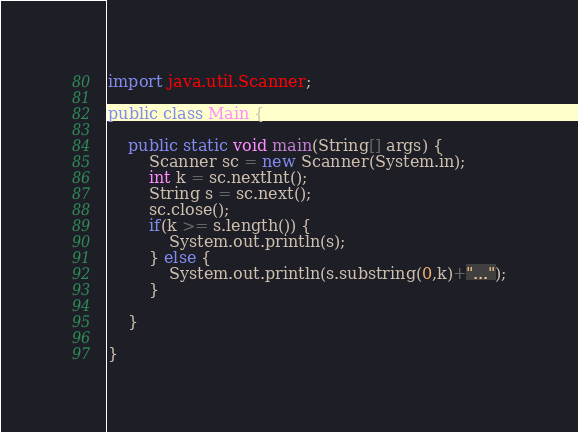Convert code to text. <code><loc_0><loc_0><loc_500><loc_500><_Java_>import java.util.Scanner;

public class Main {

	public static void main(String[] args) {
		Scanner sc = new Scanner(System.in);
		int k = sc.nextInt();
		String s = sc.next();
		sc.close();
		if(k >= s.length()) {
			System.out.println(s);
		} else {
			System.out.println(s.substring(0,k)+"...");
		}

	}

}
</code> 